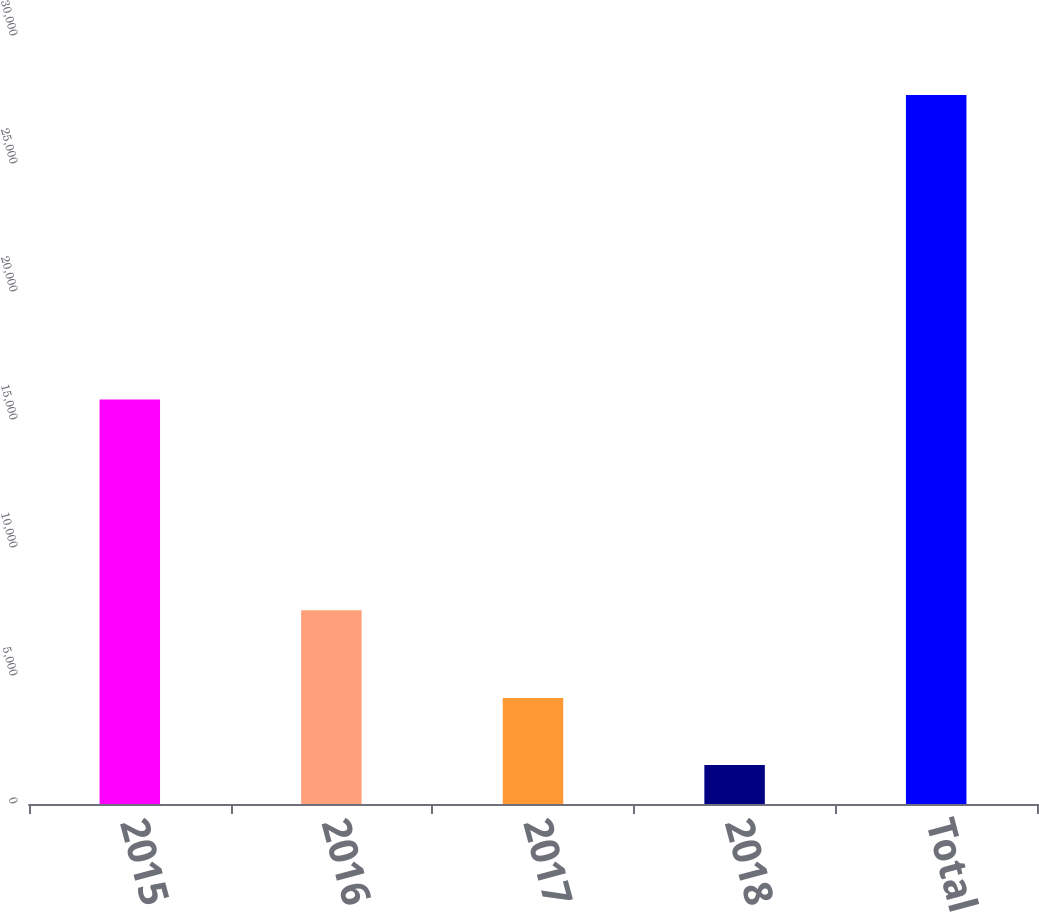Convert chart to OTSL. <chart><loc_0><loc_0><loc_500><loc_500><bar_chart><fcel>2015<fcel>2016<fcel>2017<fcel>2018<fcel>Total<nl><fcel>15802<fcel>7564<fcel>4142.2<fcel>1525<fcel>27697<nl></chart> 